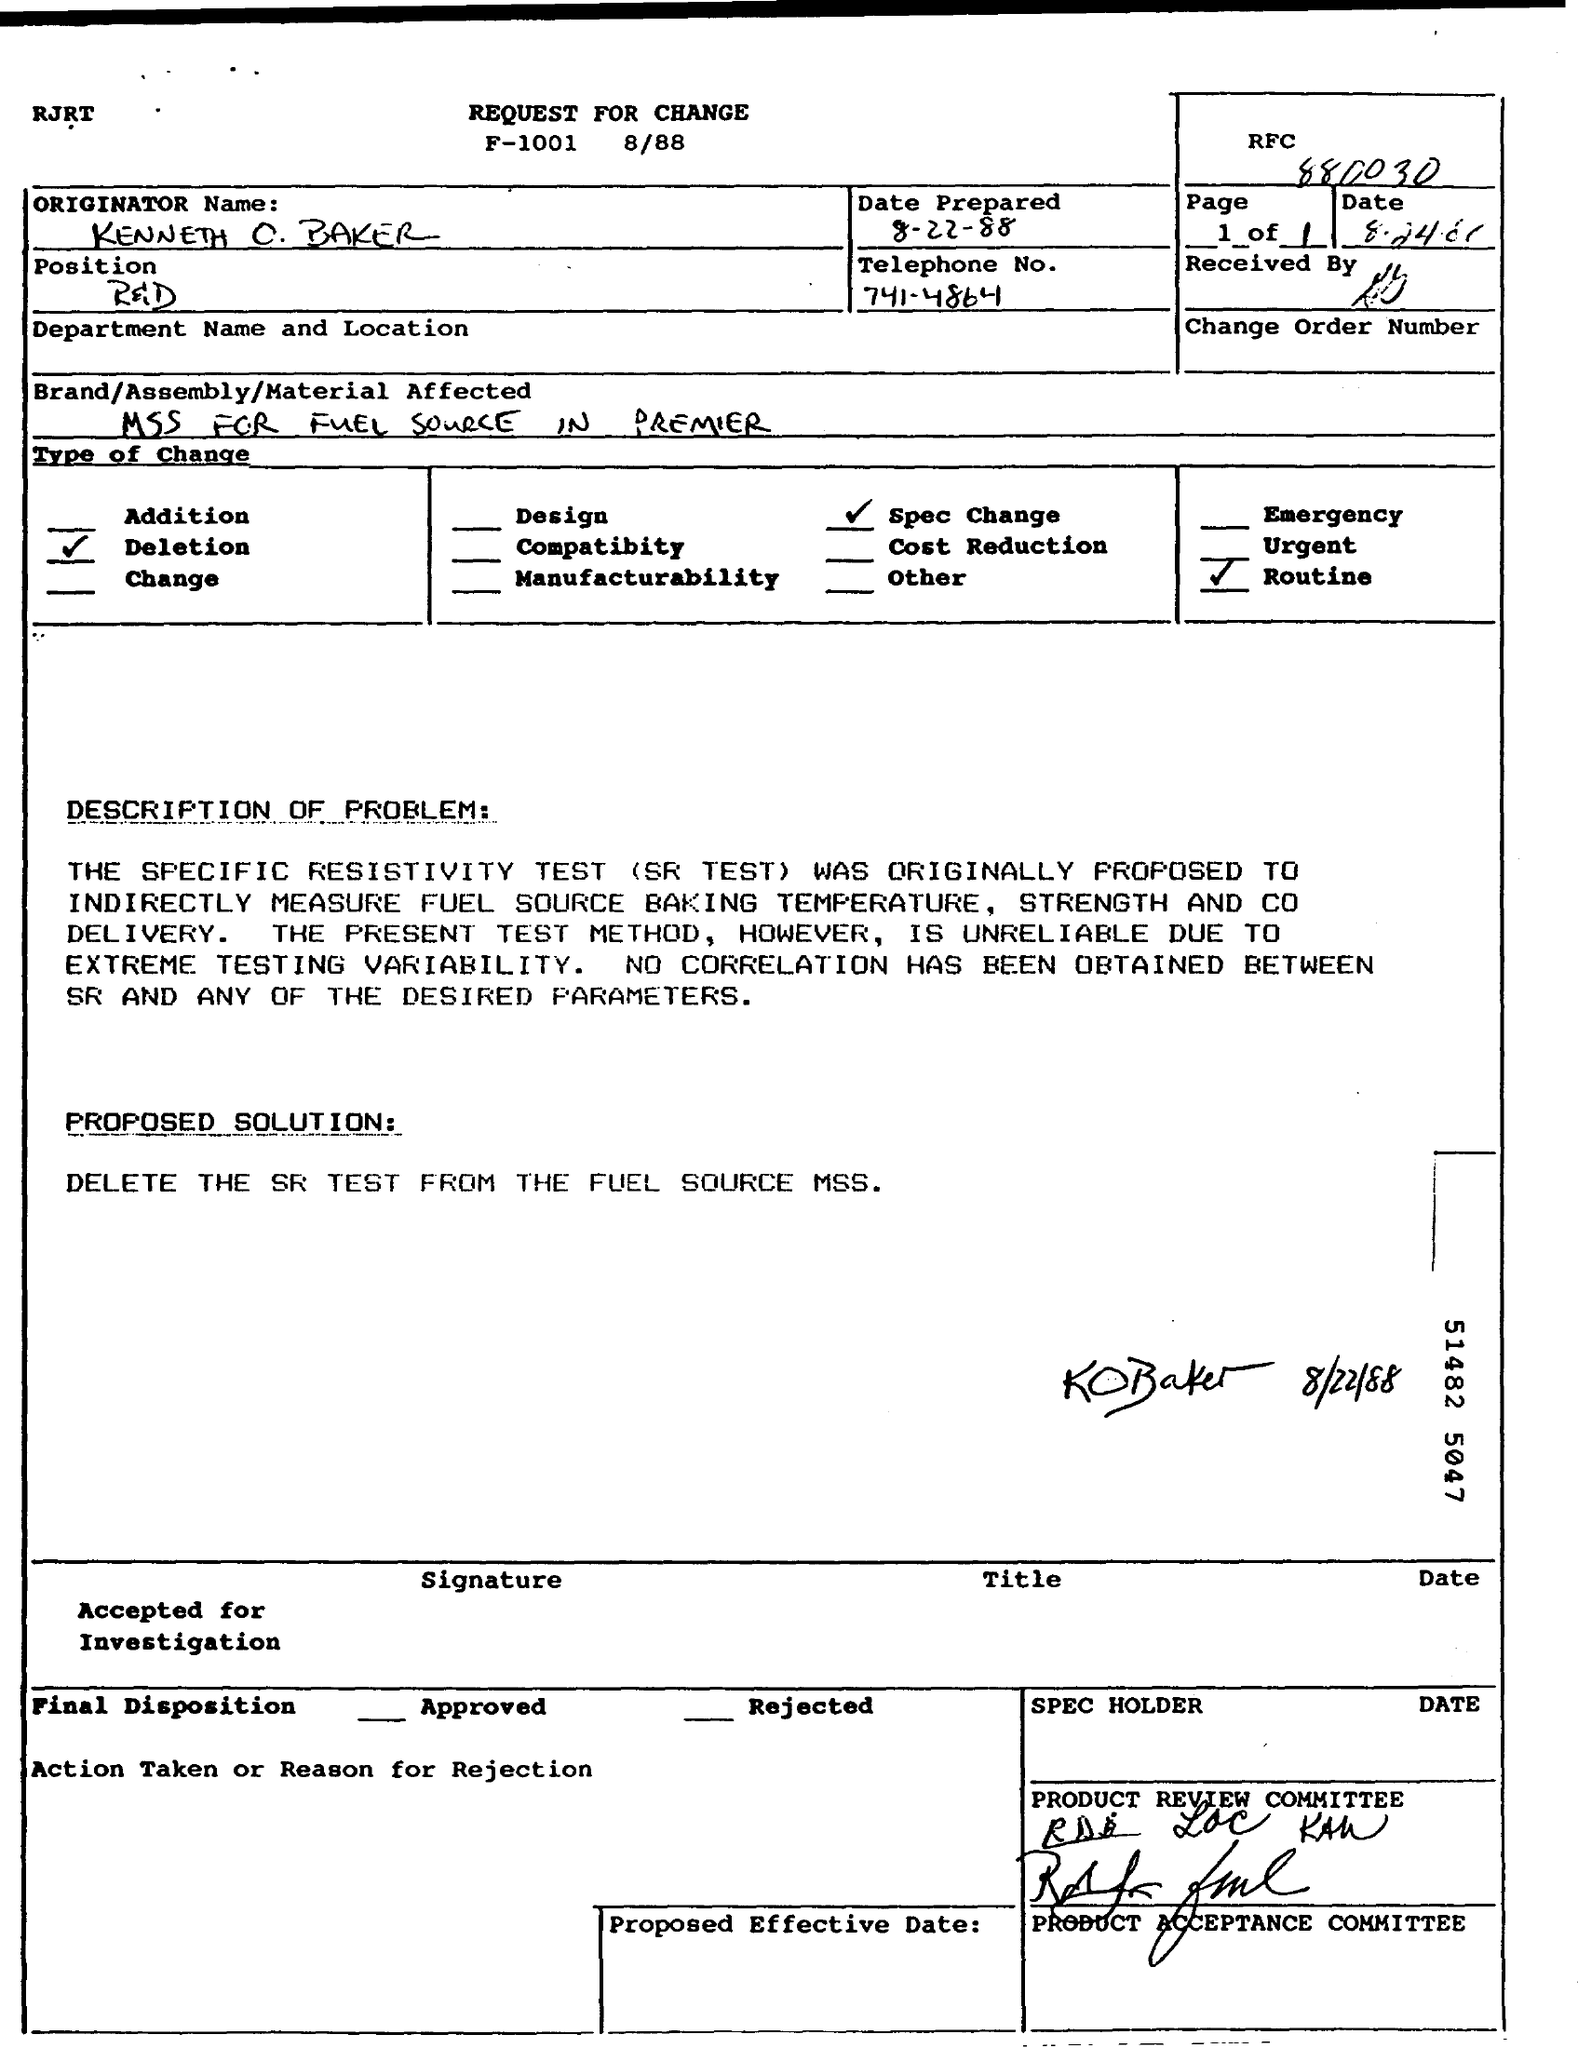What is the purpose of this document? This document is a 'Request for Change' outlining a problem with the specific resistivity test (SR test) and proposing the deletion of the SR test from the fuel source MSS as a solution. 